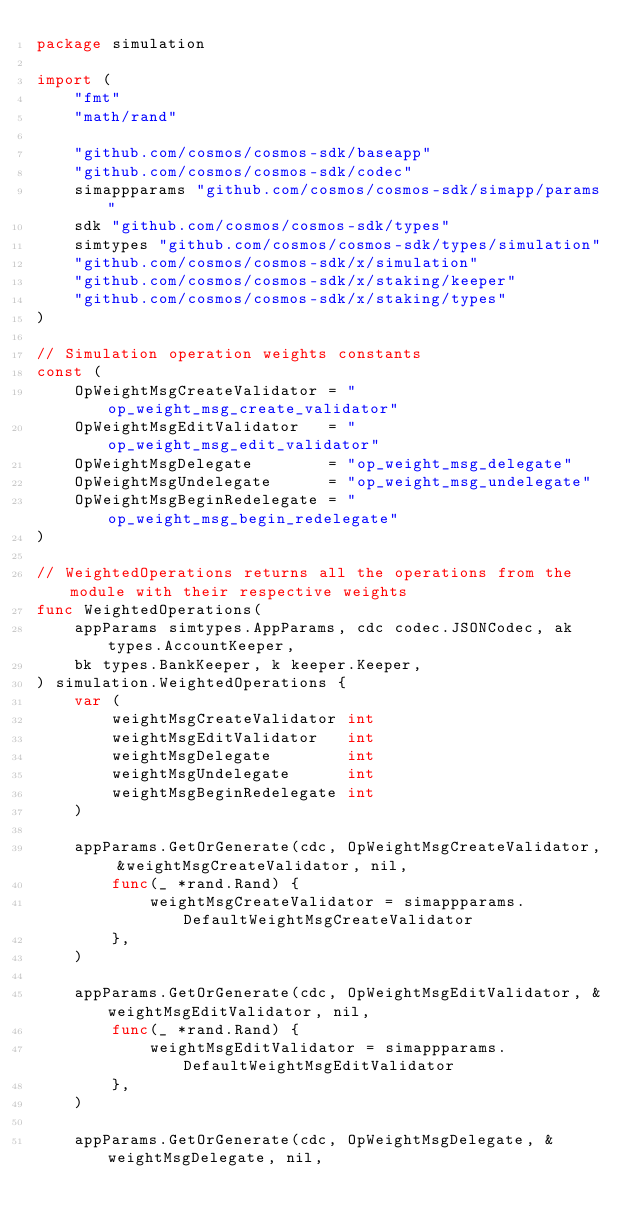<code> <loc_0><loc_0><loc_500><loc_500><_Go_>package simulation

import (
	"fmt"
	"math/rand"

	"github.com/cosmos/cosmos-sdk/baseapp"
	"github.com/cosmos/cosmos-sdk/codec"
	simappparams "github.com/cosmos/cosmos-sdk/simapp/params"
	sdk "github.com/cosmos/cosmos-sdk/types"
	simtypes "github.com/cosmos/cosmos-sdk/types/simulation"
	"github.com/cosmos/cosmos-sdk/x/simulation"
	"github.com/cosmos/cosmos-sdk/x/staking/keeper"
	"github.com/cosmos/cosmos-sdk/x/staking/types"
)

// Simulation operation weights constants
const (
	OpWeightMsgCreateValidator = "op_weight_msg_create_validator"
	OpWeightMsgEditValidator   = "op_weight_msg_edit_validator"
	OpWeightMsgDelegate        = "op_weight_msg_delegate"
	OpWeightMsgUndelegate      = "op_weight_msg_undelegate"
	OpWeightMsgBeginRedelegate = "op_weight_msg_begin_redelegate"
)

// WeightedOperations returns all the operations from the module with their respective weights
func WeightedOperations(
	appParams simtypes.AppParams, cdc codec.JSONCodec, ak types.AccountKeeper,
	bk types.BankKeeper, k keeper.Keeper,
) simulation.WeightedOperations {
	var (
		weightMsgCreateValidator int
		weightMsgEditValidator   int
		weightMsgDelegate        int
		weightMsgUndelegate      int
		weightMsgBeginRedelegate int
	)

	appParams.GetOrGenerate(cdc, OpWeightMsgCreateValidator, &weightMsgCreateValidator, nil,
		func(_ *rand.Rand) {
			weightMsgCreateValidator = simappparams.DefaultWeightMsgCreateValidator
		},
	)

	appParams.GetOrGenerate(cdc, OpWeightMsgEditValidator, &weightMsgEditValidator, nil,
		func(_ *rand.Rand) {
			weightMsgEditValidator = simappparams.DefaultWeightMsgEditValidator
		},
	)

	appParams.GetOrGenerate(cdc, OpWeightMsgDelegate, &weightMsgDelegate, nil,</code> 